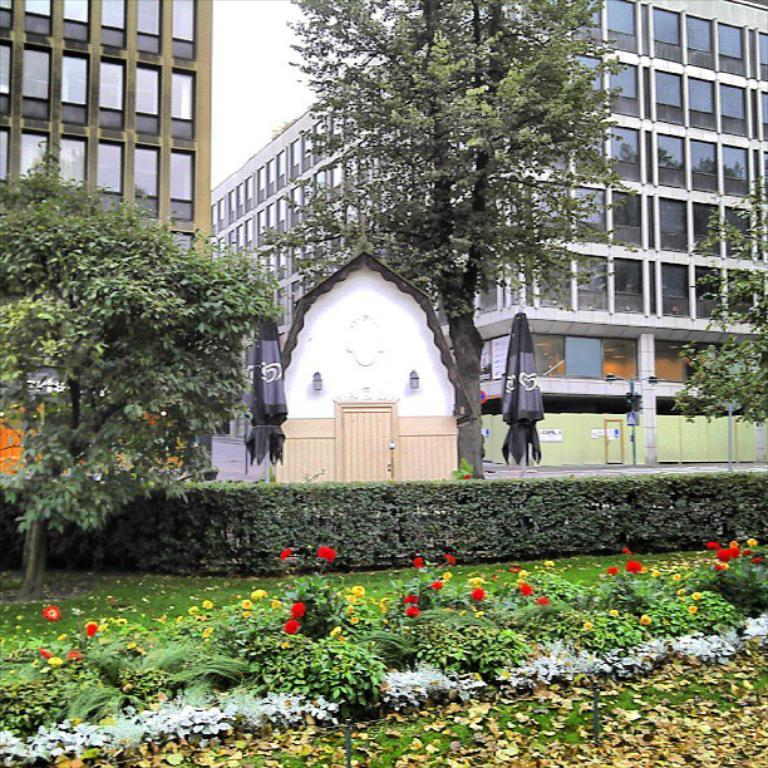What type of natural elements can be seen in the image? There are trees and plants in the image. What type of man-made structures are visible in the image? There are buildings in the image. What is visible in the background of the image? The sky is visible in the background of the image, along with other objects. What type of instrument is being played in the image? There is no instrument present in the image. What is the hope for the future in the image? The image does not depict any hopes or future plans; it is a static representation of the scene. 